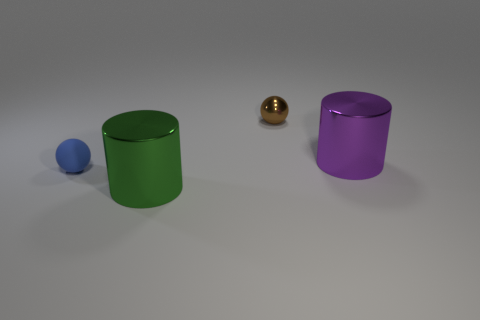How many other small spheres are made of the same material as the tiny brown ball?
Offer a terse response. 0. Are there fewer things than purple cylinders?
Ensure brevity in your answer.  No. There is a small sphere that is behind the purple cylinder; is it the same color as the matte sphere?
Offer a terse response. No. There is a brown sphere behind the cylinder that is left of the purple thing; how many big green metallic cylinders are in front of it?
Ensure brevity in your answer.  1. What number of cylinders are on the left side of the small brown shiny sphere?
Your answer should be compact. 1. The other metallic thing that is the same shape as the green metallic thing is what color?
Ensure brevity in your answer.  Purple. What is the object that is behind the small blue matte ball and in front of the metal ball made of?
Offer a very short reply. Metal. Is the size of the sphere that is to the left of the green object the same as the large purple metal cylinder?
Provide a succinct answer. No. What is the material of the brown object?
Your answer should be compact. Metal. There is a big shiny cylinder to the left of the small brown metal thing; what color is it?
Offer a terse response. Green. 